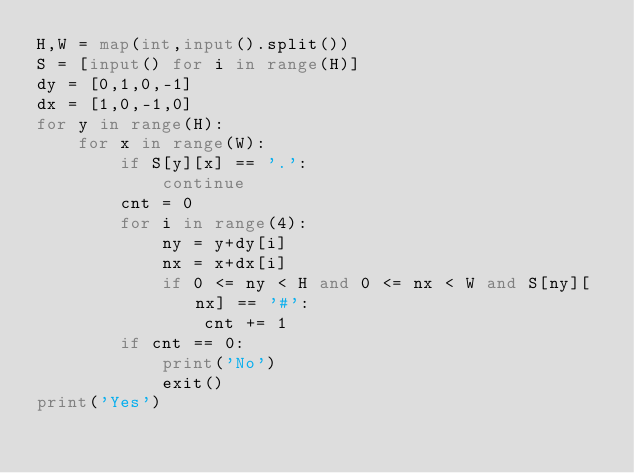<code> <loc_0><loc_0><loc_500><loc_500><_Python_>H,W = map(int,input().split())
S = [input() for i in range(H)]
dy = [0,1,0,-1]
dx = [1,0,-1,0]
for y in range(H):
    for x in range(W):
        if S[y][x] == '.':
            continue
        cnt = 0
        for i in range(4):
            ny = y+dy[i]
            nx = x+dx[i]
            if 0 <= ny < H and 0 <= nx < W and S[ny][nx] == '#':
                cnt += 1
        if cnt == 0:
            print('No')
            exit()
print('Yes')</code> 